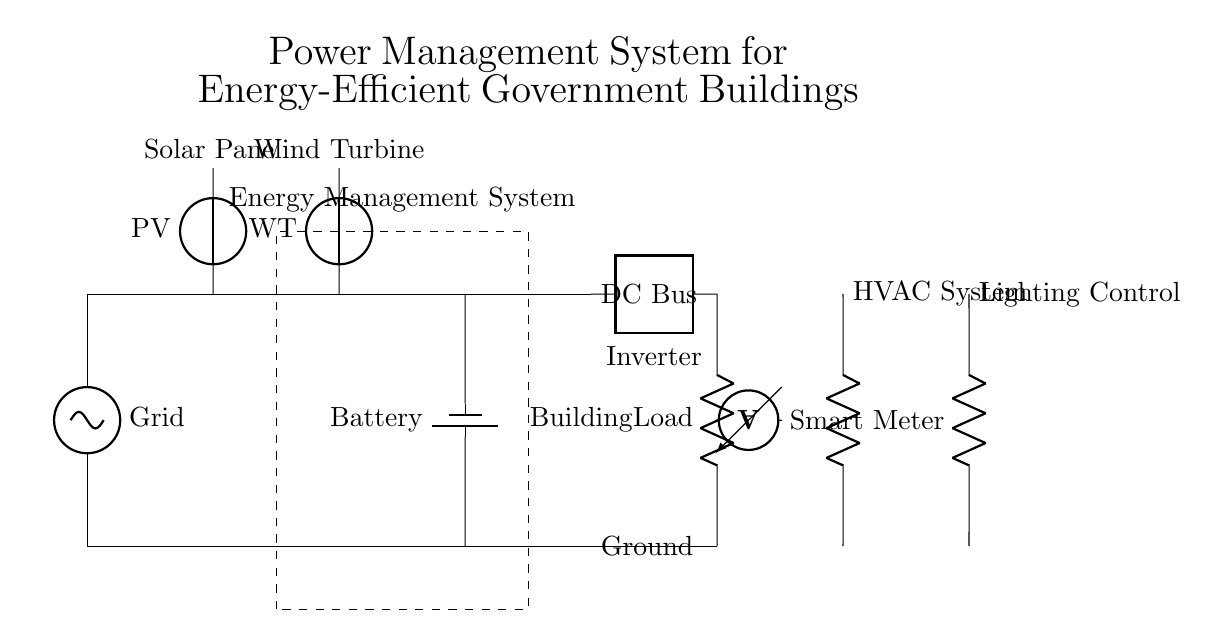What is the primary voltage source in this circuit? The primary voltage source is the grid, as indicated at the left part of the circuit diagram where it is labeled as "Grid." It is the starting point for the power supply in the system.
Answer: Grid What is the role of the energy management system? The energy management system is a crucial component in this circuit, indicated by the dashed rectangle. It likely coordinates and optimizes the energy flows from the solar panel, wind turbine, and battery to the building load, maintaining energy efficiency.
Answer: Coordination What is connected to the DC bus? The components connected to the DC bus include the solar panel, wind turbine, battery, and inverter, which together form the energy supply to the DC bus for the building load's use.
Answer: Solar panel, wind turbine, battery, inverter What type of load is connected to the inverter? The load connected to the inverter is a building load, as labeled on the right side of the circuit. This indicates that the inverter converts DC to AC for use in common building applications.
Answer: Building load What is the purpose of the smart meter in this circuit? The smart meter's role is to measure the current flowing through the system, specifically to monitor energy consumption and generation, ensuring efficient management and reporting of energy use.
Answer: Measurement How does the circuit source its power apart from the grid? Apart from the grid, the circuit sources its power from renewable energy inputs, such as the solar panel and wind turbine, which capture solar and wind energy for generation.
Answer: Renewable sources What components are used for HVAC and lighting control? The components used for HVAC and lighting control are resistors, designated for their respective functions within their circuits, which suggests they manage the loads related to heating, cooling, and lighting.
Answer: Resistors 